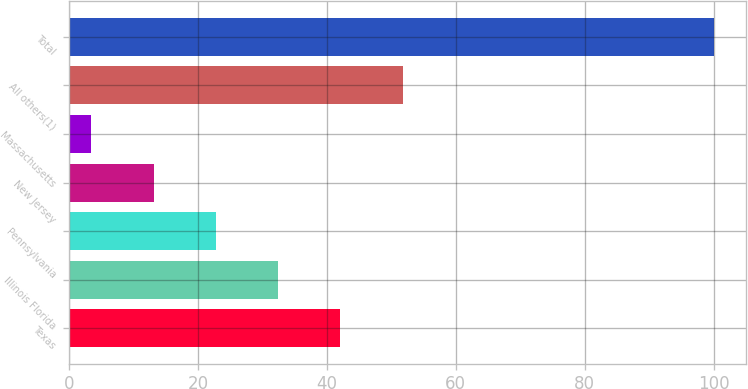<chart> <loc_0><loc_0><loc_500><loc_500><bar_chart><fcel>Texas<fcel>Illinois Florida<fcel>Pennsylvania<fcel>New Jersey<fcel>Massachusetts<fcel>All others(1)<fcel>Total<nl><fcel>42.1<fcel>32.45<fcel>22.8<fcel>13.15<fcel>3.5<fcel>51.75<fcel>100<nl></chart> 